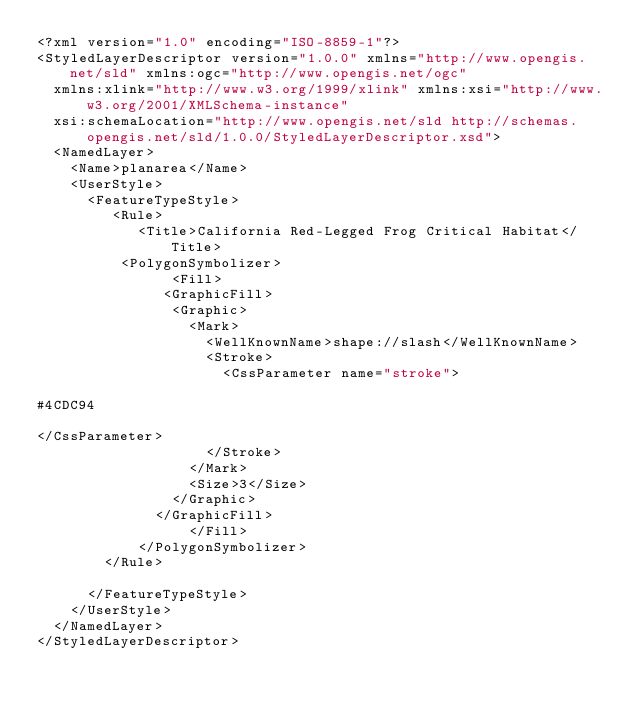<code> <loc_0><loc_0><loc_500><loc_500><_Scheme_><?xml version="1.0" encoding="ISO-8859-1"?>
<StyledLayerDescriptor version="1.0.0" xmlns="http://www.opengis.net/sld" xmlns:ogc="http://www.opengis.net/ogc"
  xmlns:xlink="http://www.w3.org/1999/xlink" xmlns:xsi="http://www.w3.org/2001/XMLSchema-instance"
  xsi:schemaLocation="http://www.opengis.net/sld http://schemas.opengis.net/sld/1.0.0/StyledLayerDescriptor.xsd">
  <NamedLayer>
    <Name>planarea</Name>
    <UserStyle>
      <FeatureTypeStyle>
         <Rule>
            <Title>California Red-Legged Frog Critical Habitat</Title>
          <PolygonSymbolizer>
                <Fill>
               <GraphicFill>
                <Graphic>
                  <Mark>
                    <WellKnownName>shape://slash</WellKnownName>
                    <Stroke>
                      <CssParameter name="stroke">

#4CDC94

</CssParameter>
                    </Stroke>
                  </Mark>
                  <Size>3</Size>
                </Graphic>
              </GraphicFill>
                  </Fill>
            </PolygonSymbolizer>
        </Rule>

      </FeatureTypeStyle>
    </UserStyle>
  </NamedLayer>
</StyledLayerDescriptor></code> 